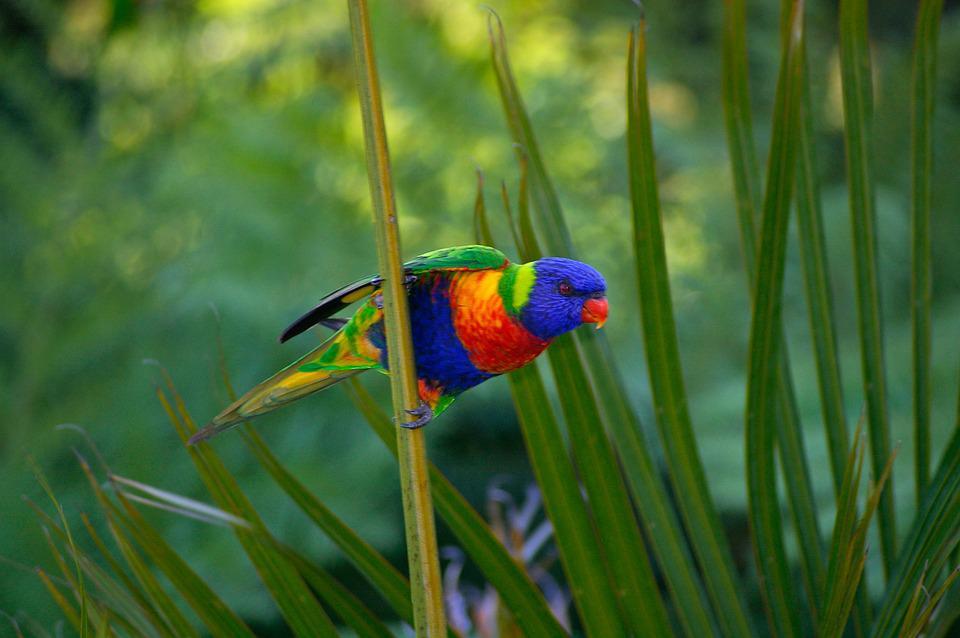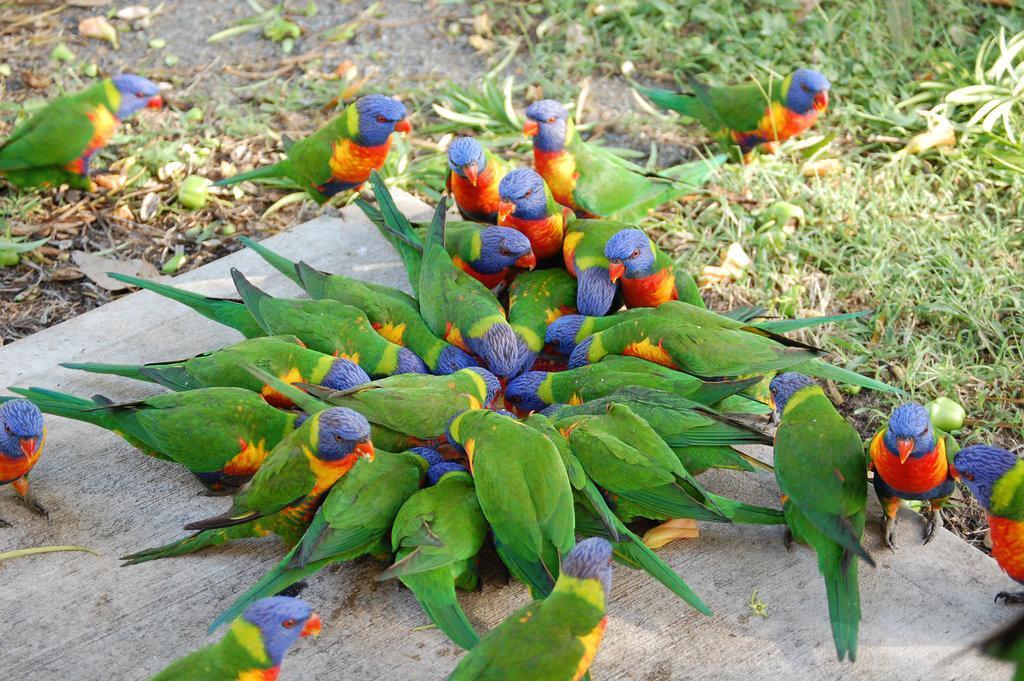The first image is the image on the left, the second image is the image on the right. Evaluate the accuracy of this statement regarding the images: "One bird stands alone.". Is it true? Answer yes or no. Yes. The first image is the image on the left, the second image is the image on the right. Considering the images on both sides, is "One image contains an entire flock of birds, 5 or more." valid? Answer yes or no. Yes. 